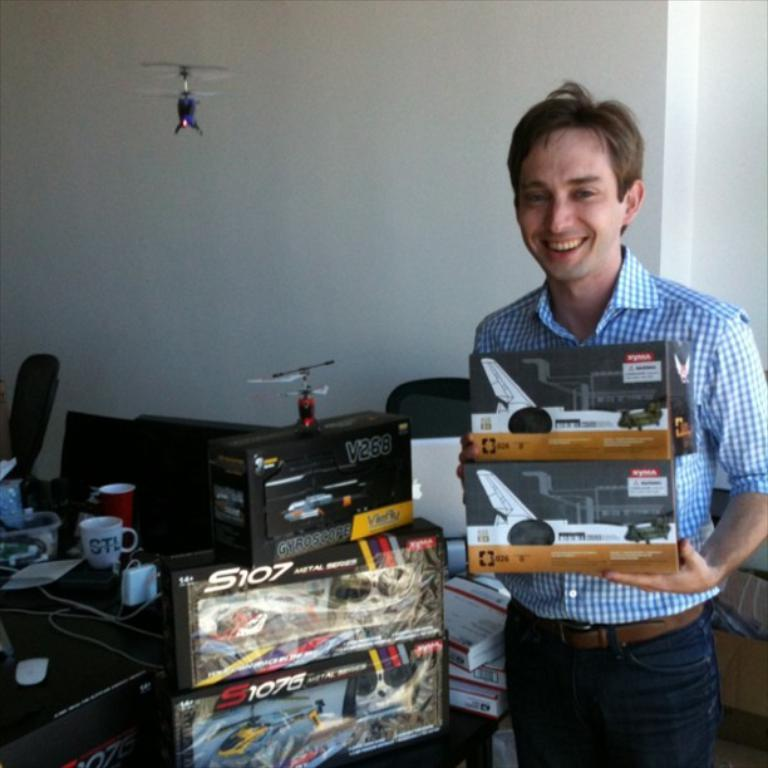<image>
Render a clear and concise summary of the photo. a person smiles with some boxes of model planes from S107 